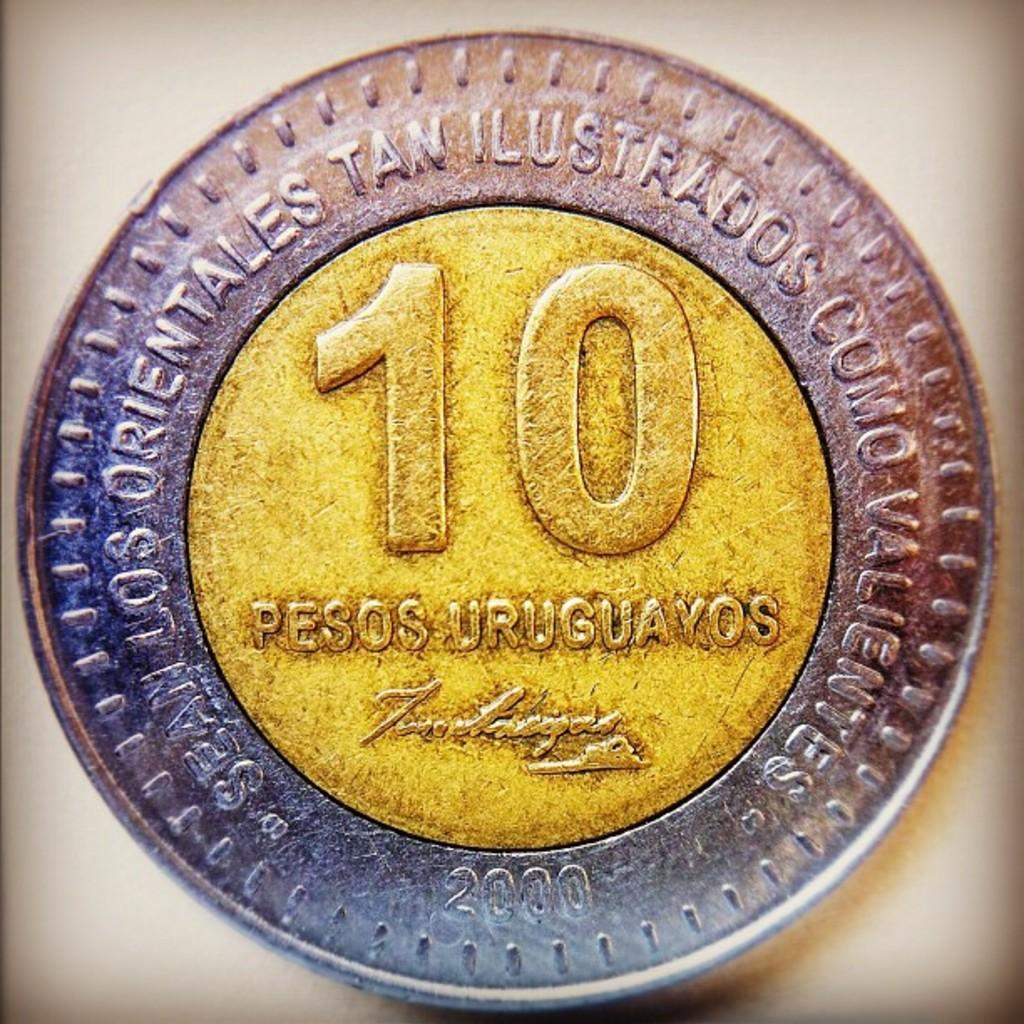<image>
Present a compact description of the photo's key features. A pesos uruguayos that is gold and silver worth 10 pesos 